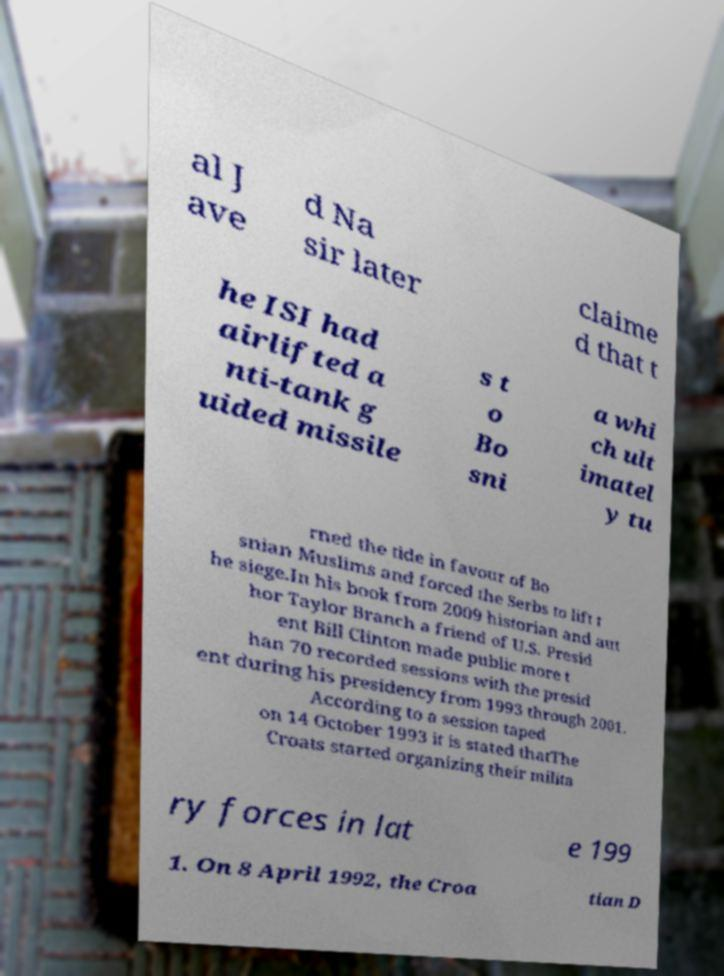For documentation purposes, I need the text within this image transcribed. Could you provide that? al J ave d Na sir later claime d that t he ISI had airlifted a nti-tank g uided missile s t o Bo sni a whi ch ult imatel y tu rned the tide in favour of Bo snian Muslims and forced the Serbs to lift t he siege.In his book from 2009 historian and aut hor Taylor Branch a friend of U.S. Presid ent Bill Clinton made public more t han 70 recorded sessions with the presid ent during his presidency from 1993 through 2001. According to a session taped on 14 October 1993 it is stated thatThe Croats started organizing their milita ry forces in lat e 199 1. On 8 April 1992, the Croa tian D 